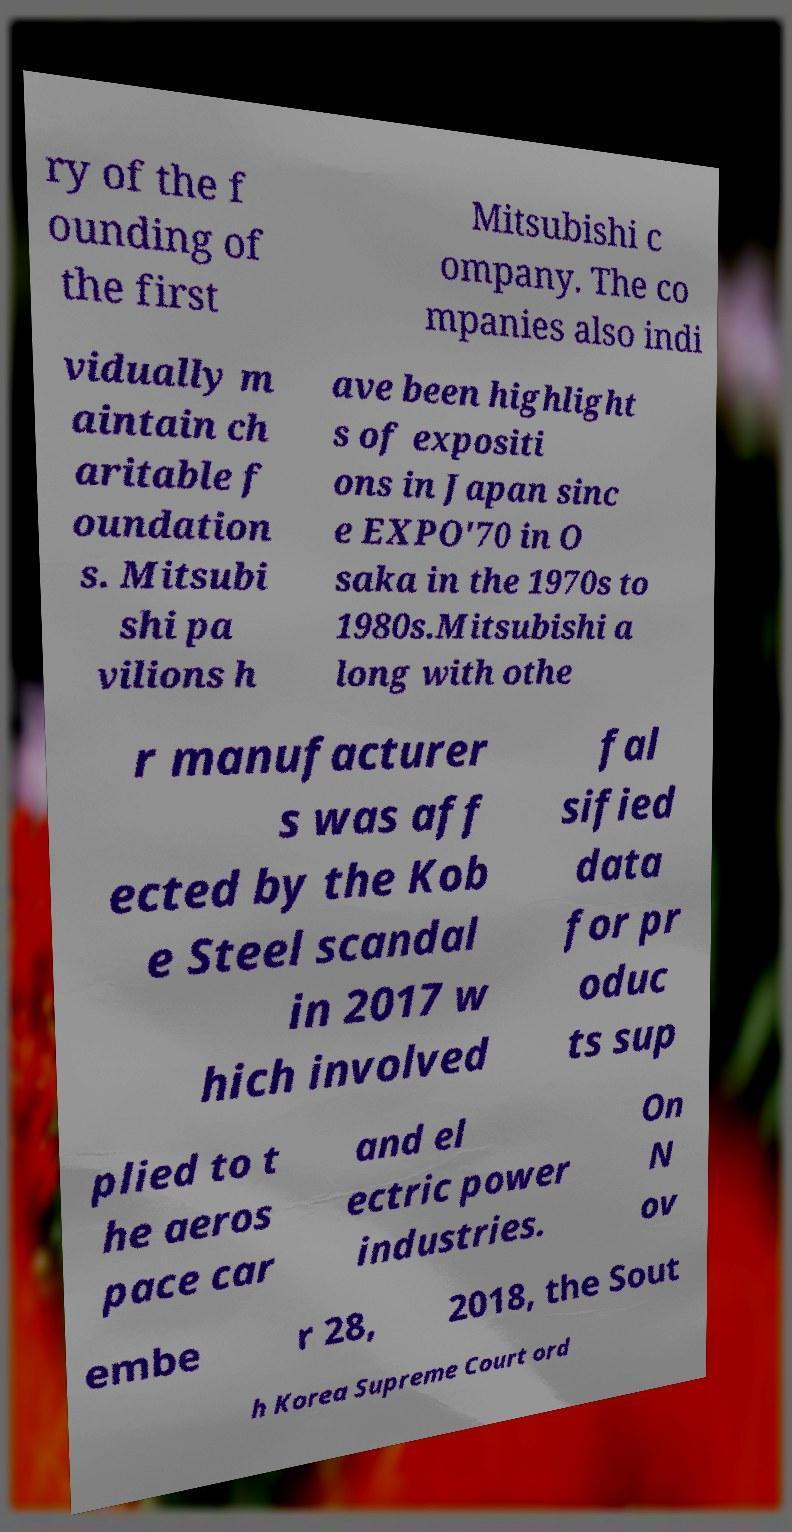I need the written content from this picture converted into text. Can you do that? ry of the f ounding of the first Mitsubishi c ompany. The co mpanies also indi vidually m aintain ch aritable f oundation s. Mitsubi shi pa vilions h ave been highlight s of expositi ons in Japan sinc e EXPO'70 in O saka in the 1970s to 1980s.Mitsubishi a long with othe r manufacturer s was aff ected by the Kob e Steel scandal in 2017 w hich involved fal sified data for pr oduc ts sup plied to t he aeros pace car and el ectric power industries. On N ov embe r 28, 2018, the Sout h Korea Supreme Court ord 